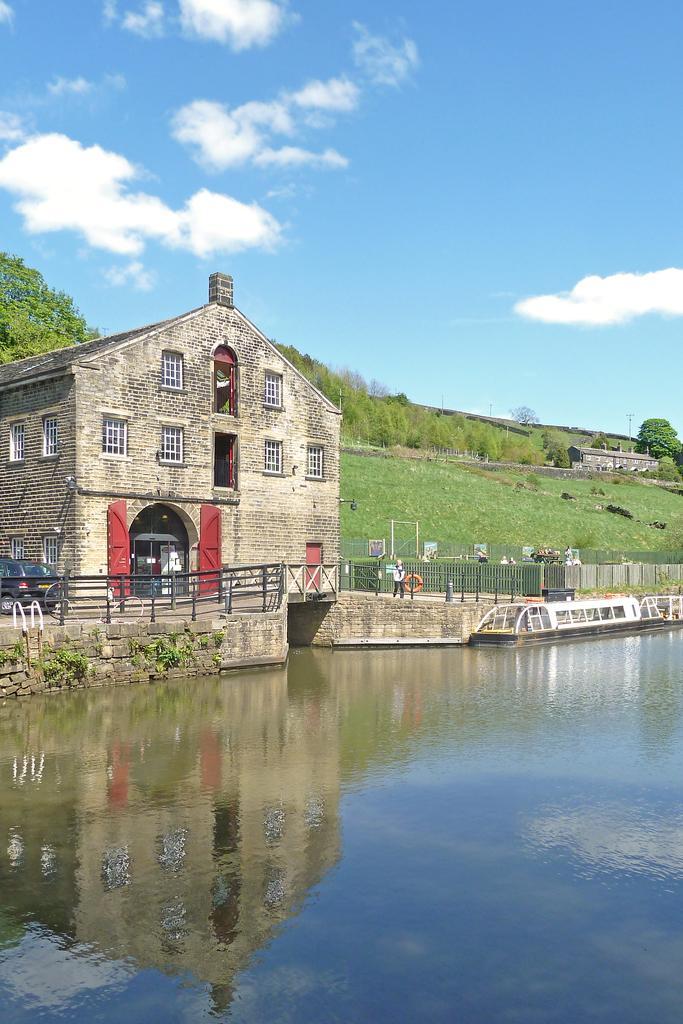Describe this image in one or two sentences. In this picture I can see the building, plants, streetlights, fencing and shed. On the right there is a boat on the water. In front of the building I can see some persons who are standing. On the left there is a black color car which is parked near to the fencing. At the top I can see the sky and clouds. 